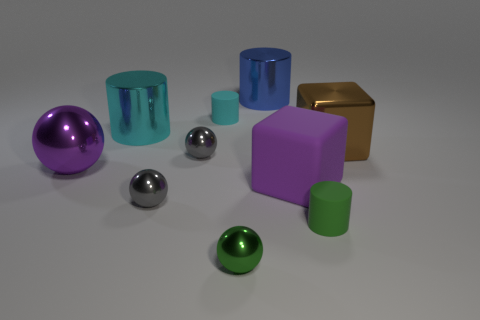What number of other things are made of the same material as the large ball?
Provide a short and direct response. 6. Does the shiny object right of the blue cylinder have the same shape as the big matte object?
Give a very brief answer. Yes. Is the large matte thing the same color as the big sphere?
Provide a succinct answer. Yes. How many objects are objects that are right of the cyan rubber thing or brown shiny cylinders?
Give a very brief answer. 5. What shape is the green rubber thing that is the same size as the cyan matte cylinder?
Your response must be concise. Cylinder. There is a rubber cylinder on the right side of the purple cube; does it have the same size as the metal object right of the large blue metallic thing?
Ensure brevity in your answer.  No. The large block that is the same material as the big cyan object is what color?
Make the answer very short. Brown. Does the large purple thing that is on the right side of the purple shiny object have the same material as the small cylinder in front of the purple metal ball?
Make the answer very short. Yes. Is there a brown block that has the same size as the blue shiny thing?
Your answer should be compact. Yes. There is a green sphere in front of the tiny green thing that is to the right of the green ball; what size is it?
Make the answer very short. Small. 